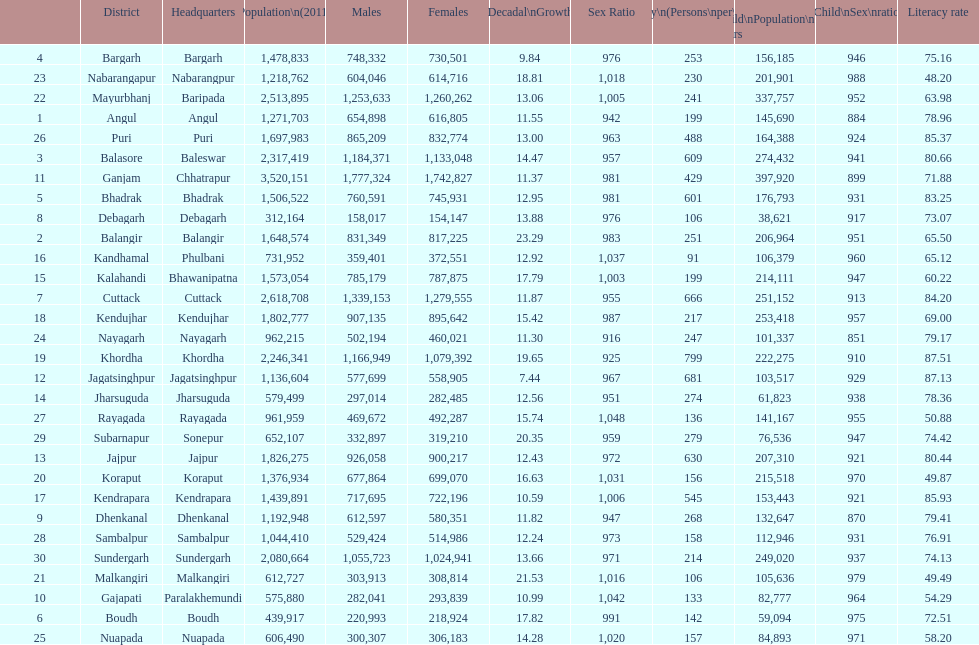Which area has a larger population, angul or cuttack? Cuttack. 